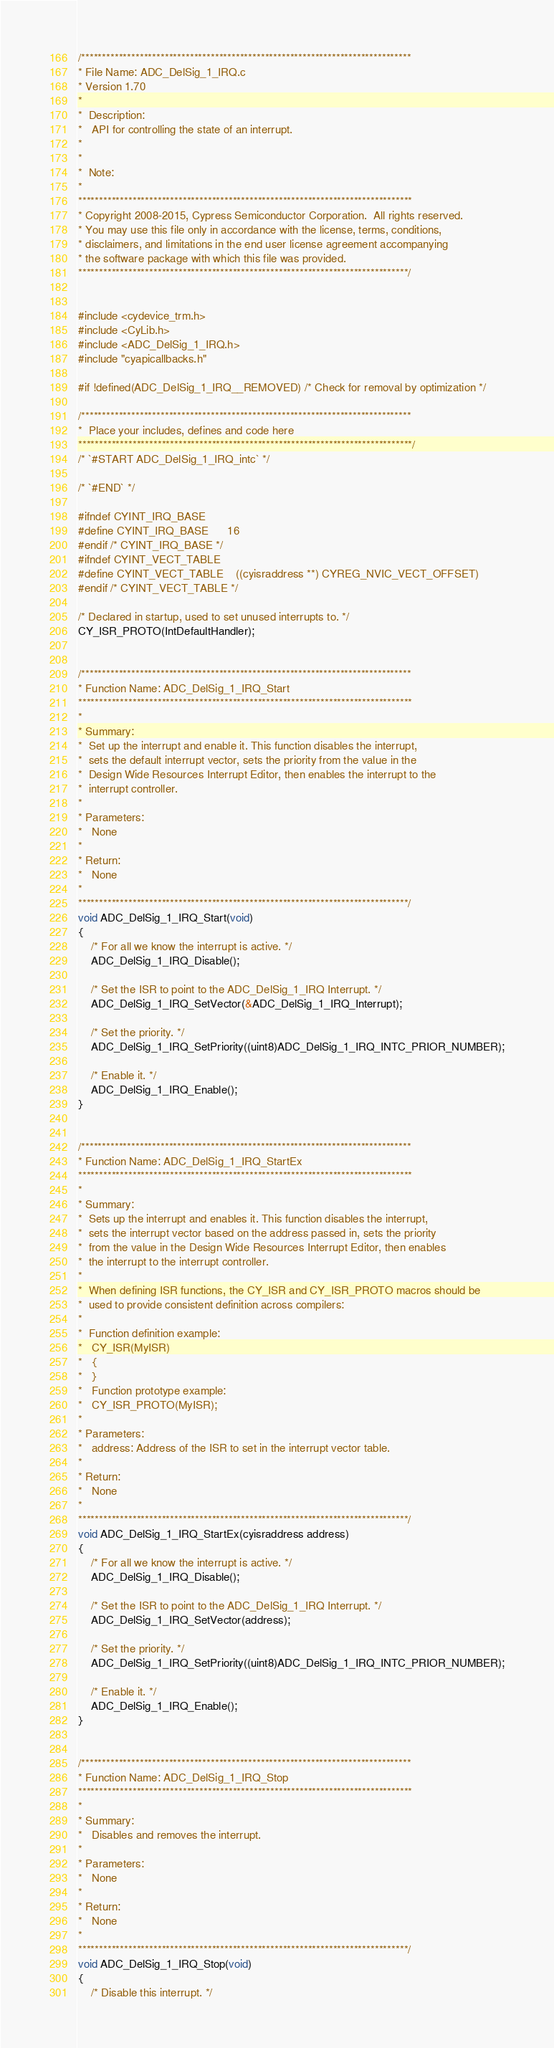<code> <loc_0><loc_0><loc_500><loc_500><_C_>/*******************************************************************************
* File Name: ADC_DelSig_1_IRQ.c  
* Version 1.70
*
*  Description:
*   API for controlling the state of an interrupt.
*
*
*  Note:
*
********************************************************************************
* Copyright 2008-2015, Cypress Semiconductor Corporation.  All rights reserved.
* You may use this file only in accordance with the license, terms, conditions, 
* disclaimers, and limitations in the end user license agreement accompanying 
* the software package with which this file was provided.
*******************************************************************************/


#include <cydevice_trm.h>
#include <CyLib.h>
#include <ADC_DelSig_1_IRQ.h>
#include "cyapicallbacks.h"

#if !defined(ADC_DelSig_1_IRQ__REMOVED) /* Check for removal by optimization */

/*******************************************************************************
*  Place your includes, defines and code here 
********************************************************************************/
/* `#START ADC_DelSig_1_IRQ_intc` */

/* `#END` */

#ifndef CYINT_IRQ_BASE
#define CYINT_IRQ_BASE      16
#endif /* CYINT_IRQ_BASE */
#ifndef CYINT_VECT_TABLE
#define CYINT_VECT_TABLE    ((cyisraddress **) CYREG_NVIC_VECT_OFFSET)
#endif /* CYINT_VECT_TABLE */

/* Declared in startup, used to set unused interrupts to. */
CY_ISR_PROTO(IntDefaultHandler);


/*******************************************************************************
* Function Name: ADC_DelSig_1_IRQ_Start
********************************************************************************
*
* Summary:
*  Set up the interrupt and enable it. This function disables the interrupt, 
*  sets the default interrupt vector, sets the priority from the value in the
*  Design Wide Resources Interrupt Editor, then enables the interrupt to the 
*  interrupt controller.
*
* Parameters:  
*   None
*
* Return:
*   None
*
*******************************************************************************/
void ADC_DelSig_1_IRQ_Start(void)
{
    /* For all we know the interrupt is active. */
    ADC_DelSig_1_IRQ_Disable();

    /* Set the ISR to point to the ADC_DelSig_1_IRQ Interrupt. */
    ADC_DelSig_1_IRQ_SetVector(&ADC_DelSig_1_IRQ_Interrupt);

    /* Set the priority. */
    ADC_DelSig_1_IRQ_SetPriority((uint8)ADC_DelSig_1_IRQ_INTC_PRIOR_NUMBER);

    /* Enable it. */
    ADC_DelSig_1_IRQ_Enable();
}


/*******************************************************************************
* Function Name: ADC_DelSig_1_IRQ_StartEx
********************************************************************************
*
* Summary:
*  Sets up the interrupt and enables it. This function disables the interrupt,
*  sets the interrupt vector based on the address passed in, sets the priority 
*  from the value in the Design Wide Resources Interrupt Editor, then enables 
*  the interrupt to the interrupt controller.
*  
*  When defining ISR functions, the CY_ISR and CY_ISR_PROTO macros should be 
*  used to provide consistent definition across compilers:
*  
*  Function definition example:
*   CY_ISR(MyISR)
*   {
*   }
*   Function prototype example:
*   CY_ISR_PROTO(MyISR);
*
* Parameters:  
*   address: Address of the ISR to set in the interrupt vector table.
*
* Return:
*   None
*
*******************************************************************************/
void ADC_DelSig_1_IRQ_StartEx(cyisraddress address)
{
    /* For all we know the interrupt is active. */
    ADC_DelSig_1_IRQ_Disable();

    /* Set the ISR to point to the ADC_DelSig_1_IRQ Interrupt. */
    ADC_DelSig_1_IRQ_SetVector(address);

    /* Set the priority. */
    ADC_DelSig_1_IRQ_SetPriority((uint8)ADC_DelSig_1_IRQ_INTC_PRIOR_NUMBER);

    /* Enable it. */
    ADC_DelSig_1_IRQ_Enable();
}


/*******************************************************************************
* Function Name: ADC_DelSig_1_IRQ_Stop
********************************************************************************
*
* Summary:
*   Disables and removes the interrupt.
*
* Parameters:  
*   None
*
* Return:
*   None
*
*******************************************************************************/
void ADC_DelSig_1_IRQ_Stop(void)
{
    /* Disable this interrupt. */</code> 